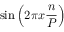<formula> <loc_0><loc_0><loc_500><loc_500>\sin \left ( 2 \pi x { \frac { n } { P } } \right )</formula> 